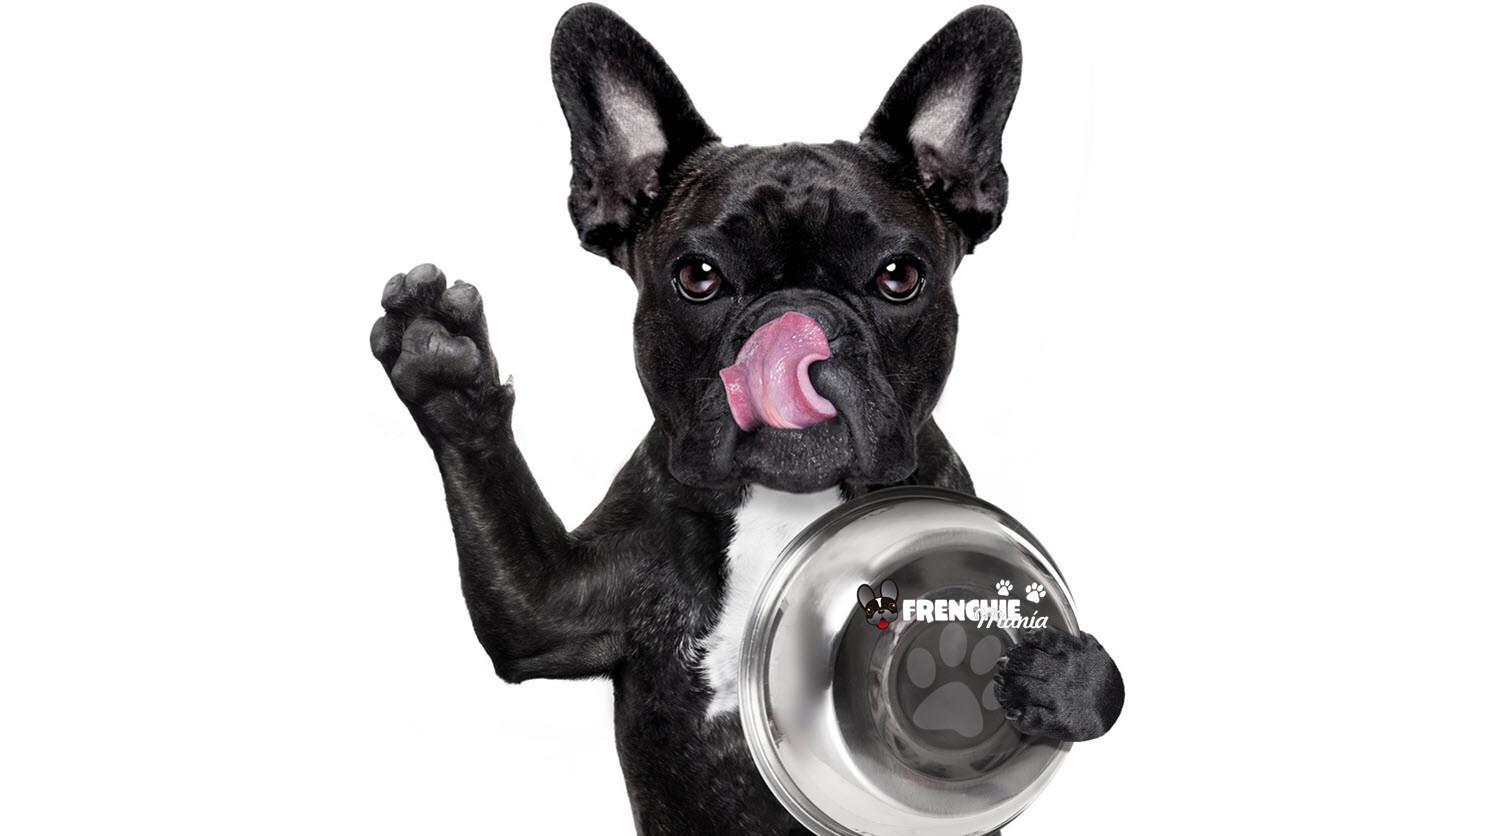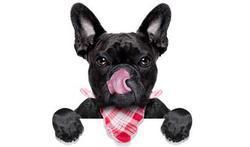The first image is the image on the left, the second image is the image on the right. Given the left and right images, does the statement "One image in the pair shows at least one dog eating." hold true? Answer yes or no. No. The first image is the image on the left, the second image is the image on the right. For the images shown, is this caption "One image features a french bulldog wearing a checkered napkin around its neck, and the other image includes a silver-colored dog food bowl and at least one bulldog." true? Answer yes or no. Yes. 